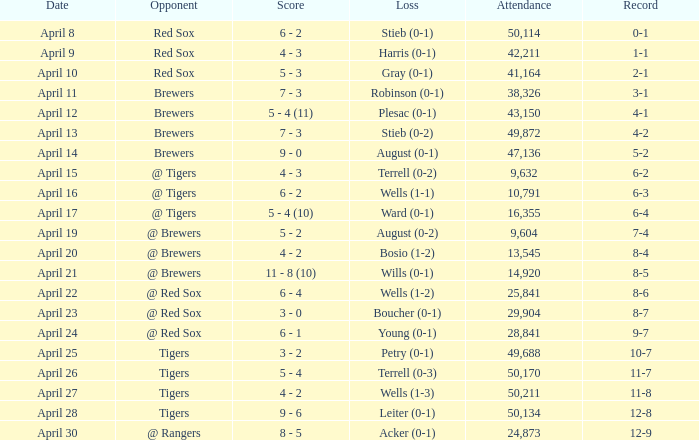Which competitor has a reduction of wells (1-3)? Tigers. 